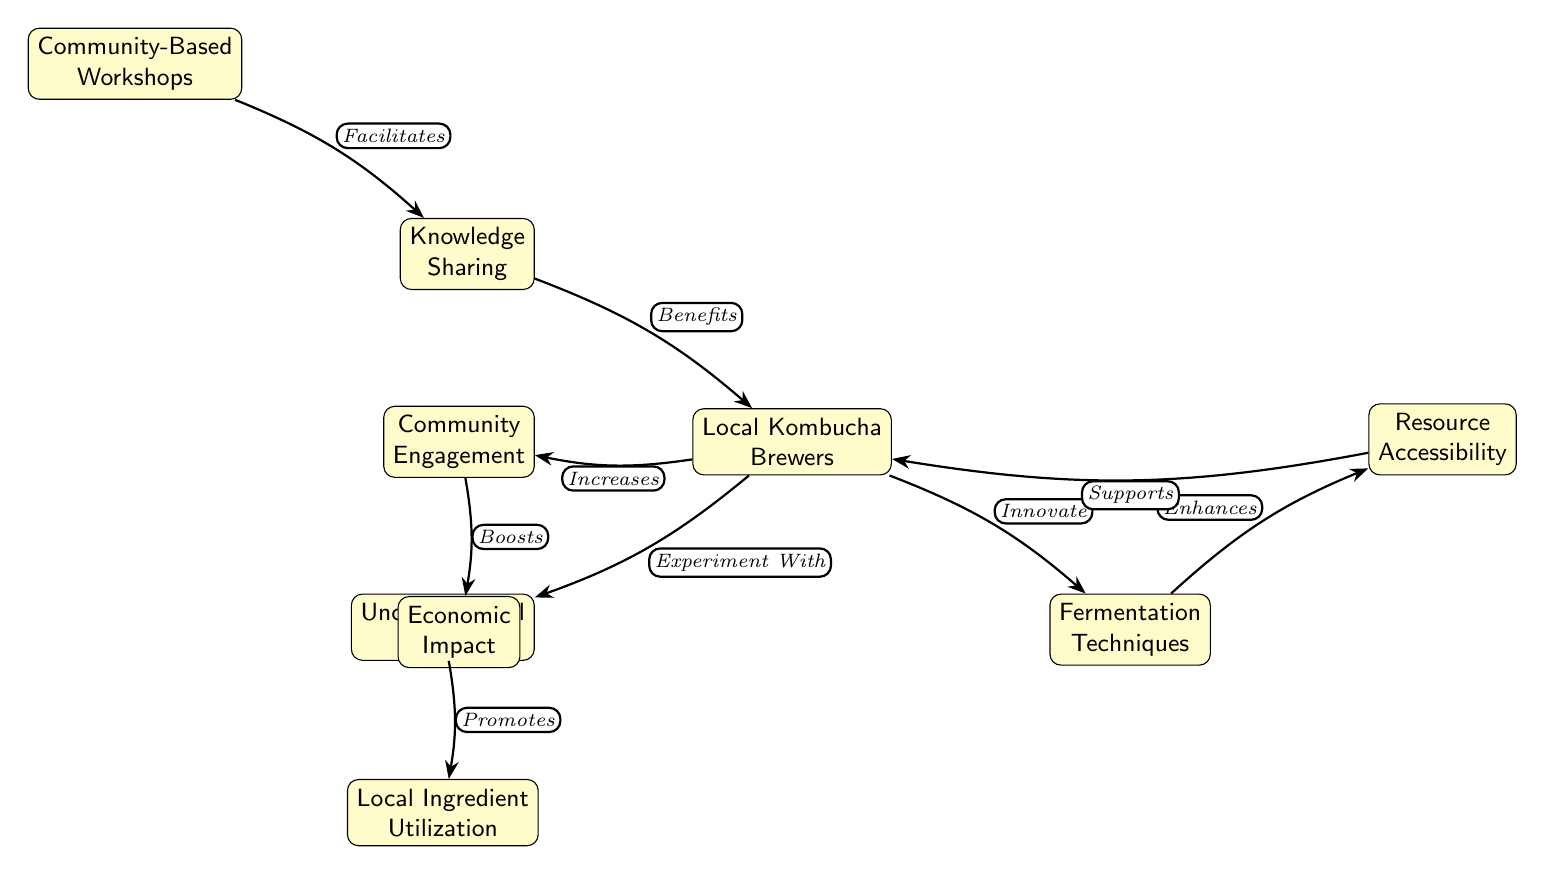What is the main starting point in the diagram? The starting point in the diagram is labeled "Community-Based Workshops," which is the first node that leads to others in the flow.
Answer: Community-Based Workshops How many nodes are present in the diagram? Counting all the nodes, we find eight distinct nodes: Community-Based Workshops, Knowledge Sharing, Local Kombucha Brewers, Unconventional Flavors, Fermentation Techniques, Resource Accessibility, Local Ingredient Utilization, Community Engagement, and Economic Impact.
Answer: 9 Which node directly influences "Local Kombucha Brewers"? The node that directly influences "Local Kombucha Brewers" is "Knowledge Sharing," as indicated by the arrow leading from it to the Local Kombucha Brewers node.
Answer: Knowledge Sharing What does "Community Engagement" boost according to the diagram? According to the diagram, "Community Engagement" boosts "Economic Impact," as shown by the arrow connecting these two nodes.
Answer: Economic Impact How does "Local Kombucha Brewers" experiment according to the diagram? The diagram shows that "Local Kombucha Brewers" experiment with "Unconventional Flavors," indicated by the directional connection from "Local Kombucha Brewers" to "Unconventional Flavors."
Answer: Unconventional Flavors What relationship exists between "Fermentation Techniques" and "Local Kombucha Brewers"? The relationship is that "Fermentation Techniques" are enhanced by "Local Kombucha Brewers," as reflected by the arrow from the Local Kombucha Brewers to the Fermentation Techniques node.
Answer: Innovate Which node supports "Local Kombucha Brewers"? "Resource Accessibility" supports "Local Kombucha Brewers," as the diagram shows this as a connecting node with a directional arrow leading to Local Kombucha Brewers.
Answer: Resource Accessibility What promotes "Local Ingredient Utilization"? "Unconventional Flavors" promotes "Local Ingredient Utilization," which is indicated in the diagram with an arrow from Unconventional Flavors to Local Ingredient Utilization.
Answer: Promotes 